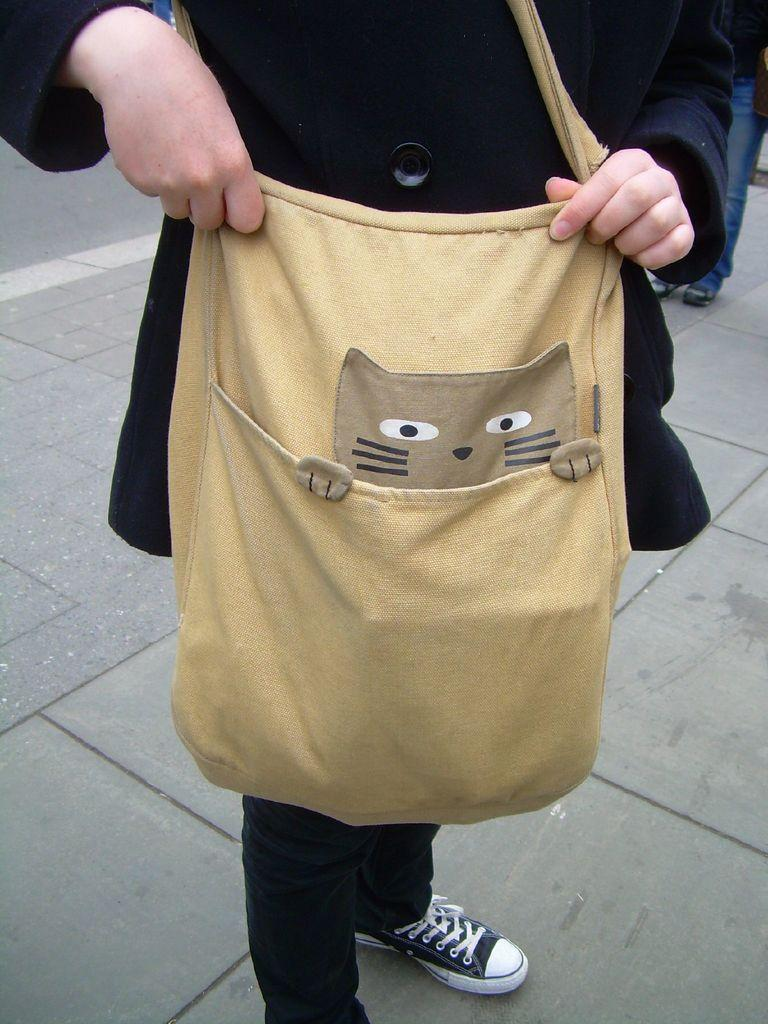What is present in the image? There is a person in the image. What is the person holding in the image? The person is holding a bag. What type of soap is the person using in the image? There is no soap present in the image; it features a person holding a bag. What sense is the person experiencing while holding the bag in the image? The image does not provide information about the person's senses or experiences. 